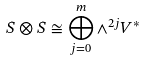Convert formula to latex. <formula><loc_0><loc_0><loc_500><loc_500>S \otimes S \cong \bigoplus _ { j = 0 } ^ { m } \wedge ^ { 2 j } V ^ { * }</formula> 